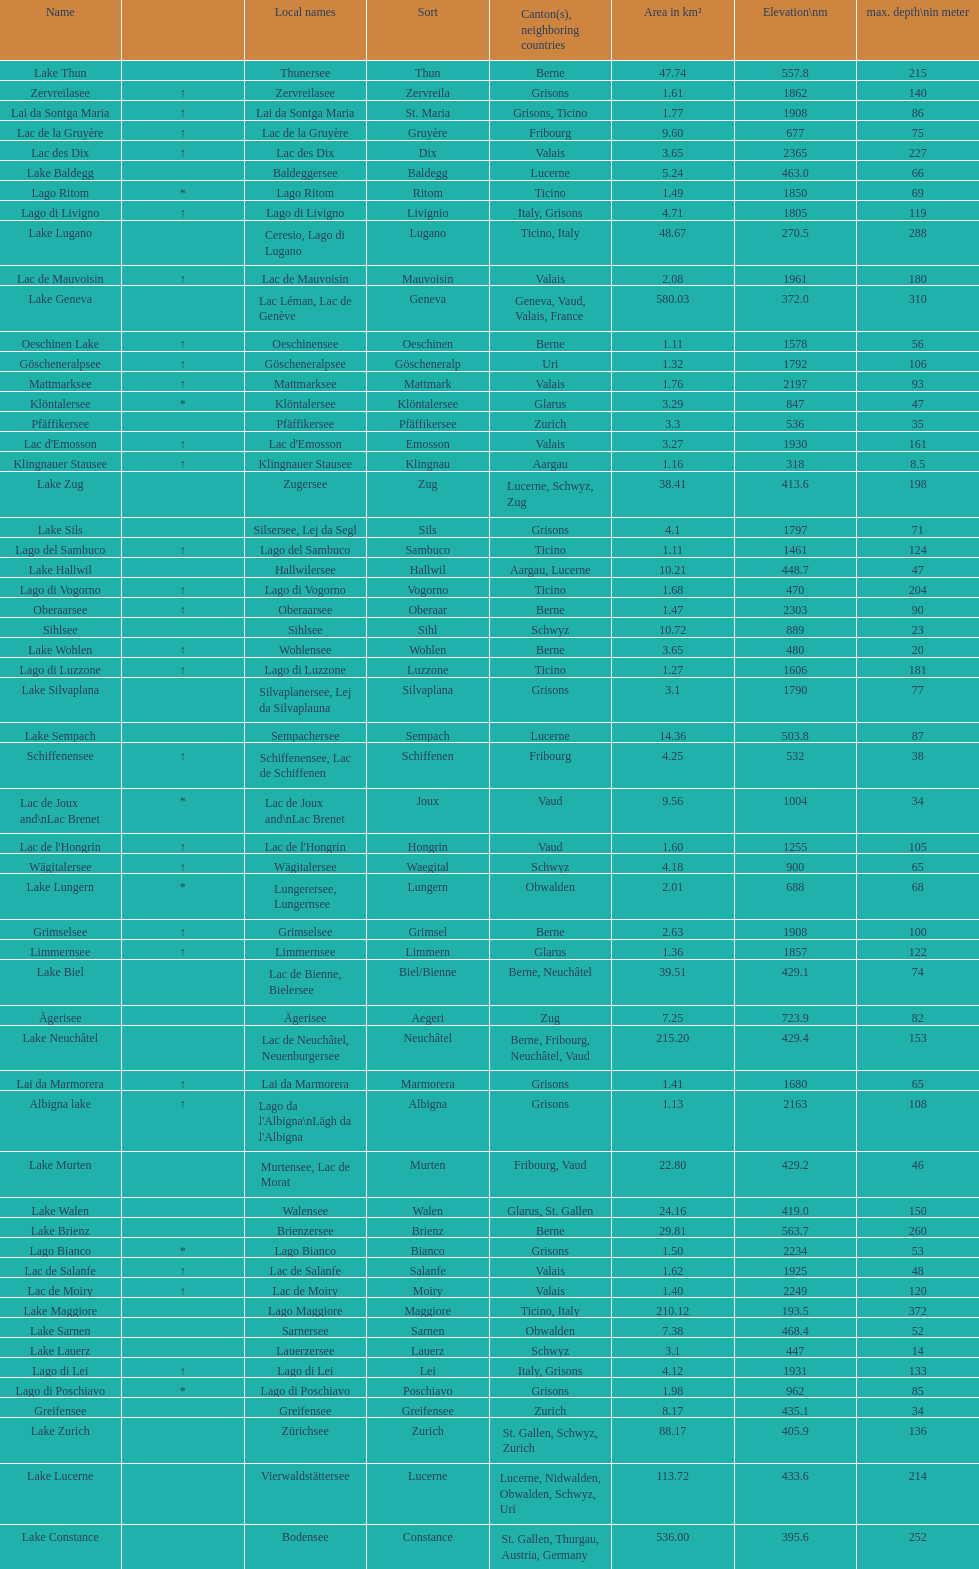What's the total max depth of lake geneva and lake constance combined? 562. 